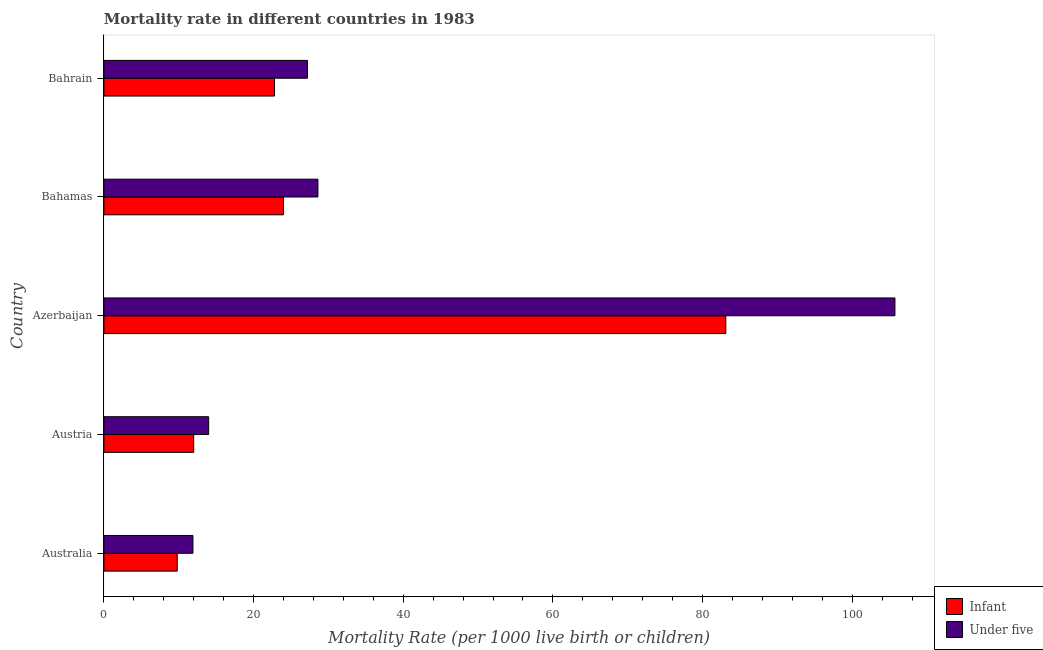How many groups of bars are there?
Keep it short and to the point. 5. How many bars are there on the 2nd tick from the top?
Provide a succinct answer. 2. How many bars are there on the 5th tick from the bottom?
Provide a succinct answer. 2. What is the label of the 2nd group of bars from the top?
Offer a terse response. Bahamas. In how many cases, is the number of bars for a given country not equal to the number of legend labels?
Ensure brevity in your answer.  0. Across all countries, what is the maximum under-5 mortality rate?
Keep it short and to the point. 105.7. In which country was the under-5 mortality rate maximum?
Your response must be concise. Azerbaijan. In which country was the infant mortality rate minimum?
Provide a short and direct response. Australia. What is the total infant mortality rate in the graph?
Keep it short and to the point. 151.7. What is the difference between the infant mortality rate in Australia and that in Azerbaijan?
Ensure brevity in your answer.  -73.3. What is the difference between the infant mortality rate in Australia and the under-5 mortality rate in Bahamas?
Ensure brevity in your answer.  -18.8. What is the average under-5 mortality rate per country?
Offer a very short reply. 37.48. What is the difference between the under-5 mortality rate and infant mortality rate in Bahamas?
Your response must be concise. 4.6. What is the ratio of the under-5 mortality rate in Australia to that in Bahamas?
Your answer should be very brief. 0.42. Is the infant mortality rate in Austria less than that in Bahrain?
Your answer should be very brief. Yes. What is the difference between the highest and the second highest infant mortality rate?
Offer a terse response. 59.1. What is the difference between the highest and the lowest infant mortality rate?
Your answer should be compact. 73.3. In how many countries, is the infant mortality rate greater than the average infant mortality rate taken over all countries?
Your answer should be very brief. 1. Is the sum of the under-5 mortality rate in Australia and Bahamas greater than the maximum infant mortality rate across all countries?
Offer a terse response. No. What does the 2nd bar from the top in Austria represents?
Provide a succinct answer. Infant. What does the 1st bar from the bottom in Australia represents?
Your response must be concise. Infant. Are all the bars in the graph horizontal?
Provide a succinct answer. Yes. How many countries are there in the graph?
Offer a very short reply. 5. What is the difference between two consecutive major ticks on the X-axis?
Your response must be concise. 20. Are the values on the major ticks of X-axis written in scientific E-notation?
Give a very brief answer. No. Does the graph contain any zero values?
Ensure brevity in your answer.  No. Does the graph contain grids?
Keep it short and to the point. No. How are the legend labels stacked?
Give a very brief answer. Vertical. What is the title of the graph?
Your response must be concise. Mortality rate in different countries in 1983. What is the label or title of the X-axis?
Your answer should be compact. Mortality Rate (per 1000 live birth or children). What is the label or title of the Y-axis?
Your answer should be compact. Country. What is the Mortality Rate (per 1000 live birth or children) of Infant in Austria?
Make the answer very short. 12. What is the Mortality Rate (per 1000 live birth or children) of Infant in Azerbaijan?
Keep it short and to the point. 83.1. What is the Mortality Rate (per 1000 live birth or children) of Under five in Azerbaijan?
Your response must be concise. 105.7. What is the Mortality Rate (per 1000 live birth or children) in Under five in Bahamas?
Provide a succinct answer. 28.6. What is the Mortality Rate (per 1000 live birth or children) of Infant in Bahrain?
Offer a terse response. 22.8. What is the Mortality Rate (per 1000 live birth or children) in Under five in Bahrain?
Ensure brevity in your answer.  27.2. Across all countries, what is the maximum Mortality Rate (per 1000 live birth or children) in Infant?
Provide a short and direct response. 83.1. Across all countries, what is the maximum Mortality Rate (per 1000 live birth or children) in Under five?
Your response must be concise. 105.7. Across all countries, what is the minimum Mortality Rate (per 1000 live birth or children) in Infant?
Your answer should be very brief. 9.8. What is the total Mortality Rate (per 1000 live birth or children) in Infant in the graph?
Provide a short and direct response. 151.7. What is the total Mortality Rate (per 1000 live birth or children) of Under five in the graph?
Give a very brief answer. 187.4. What is the difference between the Mortality Rate (per 1000 live birth or children) in Infant in Australia and that in Austria?
Your answer should be very brief. -2.2. What is the difference between the Mortality Rate (per 1000 live birth or children) of Under five in Australia and that in Austria?
Offer a very short reply. -2.1. What is the difference between the Mortality Rate (per 1000 live birth or children) in Infant in Australia and that in Azerbaijan?
Provide a succinct answer. -73.3. What is the difference between the Mortality Rate (per 1000 live birth or children) of Under five in Australia and that in Azerbaijan?
Keep it short and to the point. -93.8. What is the difference between the Mortality Rate (per 1000 live birth or children) in Under five in Australia and that in Bahamas?
Give a very brief answer. -16.7. What is the difference between the Mortality Rate (per 1000 live birth or children) of Infant in Australia and that in Bahrain?
Your response must be concise. -13. What is the difference between the Mortality Rate (per 1000 live birth or children) in Under five in Australia and that in Bahrain?
Give a very brief answer. -15.3. What is the difference between the Mortality Rate (per 1000 live birth or children) in Infant in Austria and that in Azerbaijan?
Provide a succinct answer. -71.1. What is the difference between the Mortality Rate (per 1000 live birth or children) of Under five in Austria and that in Azerbaijan?
Provide a succinct answer. -91.7. What is the difference between the Mortality Rate (per 1000 live birth or children) in Infant in Austria and that in Bahamas?
Offer a terse response. -12. What is the difference between the Mortality Rate (per 1000 live birth or children) in Under five in Austria and that in Bahamas?
Offer a terse response. -14.6. What is the difference between the Mortality Rate (per 1000 live birth or children) of Under five in Austria and that in Bahrain?
Offer a very short reply. -13.2. What is the difference between the Mortality Rate (per 1000 live birth or children) of Infant in Azerbaijan and that in Bahamas?
Offer a very short reply. 59.1. What is the difference between the Mortality Rate (per 1000 live birth or children) of Under five in Azerbaijan and that in Bahamas?
Your answer should be compact. 77.1. What is the difference between the Mortality Rate (per 1000 live birth or children) of Infant in Azerbaijan and that in Bahrain?
Provide a short and direct response. 60.3. What is the difference between the Mortality Rate (per 1000 live birth or children) of Under five in Azerbaijan and that in Bahrain?
Your answer should be compact. 78.5. What is the difference between the Mortality Rate (per 1000 live birth or children) of Infant in Australia and the Mortality Rate (per 1000 live birth or children) of Under five in Austria?
Give a very brief answer. -4.2. What is the difference between the Mortality Rate (per 1000 live birth or children) of Infant in Australia and the Mortality Rate (per 1000 live birth or children) of Under five in Azerbaijan?
Your answer should be compact. -95.9. What is the difference between the Mortality Rate (per 1000 live birth or children) in Infant in Australia and the Mortality Rate (per 1000 live birth or children) in Under five in Bahamas?
Keep it short and to the point. -18.8. What is the difference between the Mortality Rate (per 1000 live birth or children) of Infant in Australia and the Mortality Rate (per 1000 live birth or children) of Under five in Bahrain?
Your answer should be very brief. -17.4. What is the difference between the Mortality Rate (per 1000 live birth or children) in Infant in Austria and the Mortality Rate (per 1000 live birth or children) in Under five in Azerbaijan?
Offer a very short reply. -93.7. What is the difference between the Mortality Rate (per 1000 live birth or children) in Infant in Austria and the Mortality Rate (per 1000 live birth or children) in Under five in Bahamas?
Keep it short and to the point. -16.6. What is the difference between the Mortality Rate (per 1000 live birth or children) of Infant in Austria and the Mortality Rate (per 1000 live birth or children) of Under five in Bahrain?
Give a very brief answer. -15.2. What is the difference between the Mortality Rate (per 1000 live birth or children) of Infant in Azerbaijan and the Mortality Rate (per 1000 live birth or children) of Under five in Bahamas?
Ensure brevity in your answer.  54.5. What is the difference between the Mortality Rate (per 1000 live birth or children) in Infant in Azerbaijan and the Mortality Rate (per 1000 live birth or children) in Under five in Bahrain?
Your answer should be very brief. 55.9. What is the average Mortality Rate (per 1000 live birth or children) of Infant per country?
Provide a short and direct response. 30.34. What is the average Mortality Rate (per 1000 live birth or children) in Under five per country?
Keep it short and to the point. 37.48. What is the difference between the Mortality Rate (per 1000 live birth or children) in Infant and Mortality Rate (per 1000 live birth or children) in Under five in Azerbaijan?
Ensure brevity in your answer.  -22.6. What is the difference between the Mortality Rate (per 1000 live birth or children) in Infant and Mortality Rate (per 1000 live birth or children) in Under five in Bahrain?
Offer a terse response. -4.4. What is the ratio of the Mortality Rate (per 1000 live birth or children) in Infant in Australia to that in Austria?
Offer a terse response. 0.82. What is the ratio of the Mortality Rate (per 1000 live birth or children) in Infant in Australia to that in Azerbaijan?
Provide a short and direct response. 0.12. What is the ratio of the Mortality Rate (per 1000 live birth or children) of Under five in Australia to that in Azerbaijan?
Provide a short and direct response. 0.11. What is the ratio of the Mortality Rate (per 1000 live birth or children) of Infant in Australia to that in Bahamas?
Make the answer very short. 0.41. What is the ratio of the Mortality Rate (per 1000 live birth or children) of Under five in Australia to that in Bahamas?
Your response must be concise. 0.42. What is the ratio of the Mortality Rate (per 1000 live birth or children) of Infant in Australia to that in Bahrain?
Provide a short and direct response. 0.43. What is the ratio of the Mortality Rate (per 1000 live birth or children) in Under five in Australia to that in Bahrain?
Give a very brief answer. 0.44. What is the ratio of the Mortality Rate (per 1000 live birth or children) in Infant in Austria to that in Azerbaijan?
Give a very brief answer. 0.14. What is the ratio of the Mortality Rate (per 1000 live birth or children) in Under five in Austria to that in Azerbaijan?
Provide a short and direct response. 0.13. What is the ratio of the Mortality Rate (per 1000 live birth or children) in Under five in Austria to that in Bahamas?
Give a very brief answer. 0.49. What is the ratio of the Mortality Rate (per 1000 live birth or children) in Infant in Austria to that in Bahrain?
Keep it short and to the point. 0.53. What is the ratio of the Mortality Rate (per 1000 live birth or children) of Under five in Austria to that in Bahrain?
Ensure brevity in your answer.  0.51. What is the ratio of the Mortality Rate (per 1000 live birth or children) of Infant in Azerbaijan to that in Bahamas?
Your answer should be very brief. 3.46. What is the ratio of the Mortality Rate (per 1000 live birth or children) of Under five in Azerbaijan to that in Bahamas?
Make the answer very short. 3.7. What is the ratio of the Mortality Rate (per 1000 live birth or children) in Infant in Azerbaijan to that in Bahrain?
Your response must be concise. 3.64. What is the ratio of the Mortality Rate (per 1000 live birth or children) of Under five in Azerbaijan to that in Bahrain?
Your response must be concise. 3.89. What is the ratio of the Mortality Rate (per 1000 live birth or children) in Infant in Bahamas to that in Bahrain?
Your answer should be compact. 1.05. What is the ratio of the Mortality Rate (per 1000 live birth or children) of Under five in Bahamas to that in Bahrain?
Ensure brevity in your answer.  1.05. What is the difference between the highest and the second highest Mortality Rate (per 1000 live birth or children) of Infant?
Make the answer very short. 59.1. What is the difference between the highest and the second highest Mortality Rate (per 1000 live birth or children) in Under five?
Your answer should be compact. 77.1. What is the difference between the highest and the lowest Mortality Rate (per 1000 live birth or children) in Infant?
Give a very brief answer. 73.3. What is the difference between the highest and the lowest Mortality Rate (per 1000 live birth or children) of Under five?
Give a very brief answer. 93.8. 